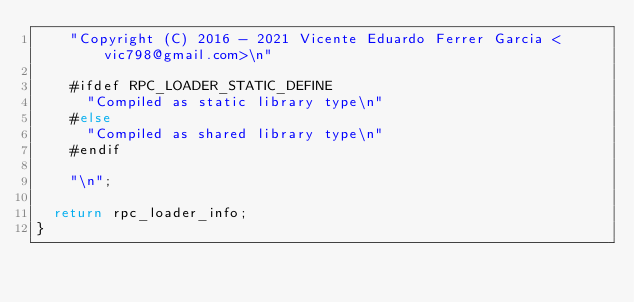<code> <loc_0><loc_0><loc_500><loc_500><_C_>		"Copyright (C) 2016 - 2021 Vicente Eduardo Ferrer Garcia <vic798@gmail.com>\n"

		#ifdef RPC_LOADER_STATIC_DEFINE
			"Compiled as static library type\n"
		#else
			"Compiled as shared library type\n"
		#endif

		"\n";

	return rpc_loader_info;
}
</code> 